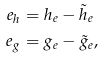<formula> <loc_0><loc_0><loc_500><loc_500>e _ { h } & = h _ { e } - \tilde { h } _ { e } \\ e _ { g } & = g _ { e } - \tilde { g } _ { e } ,</formula> 